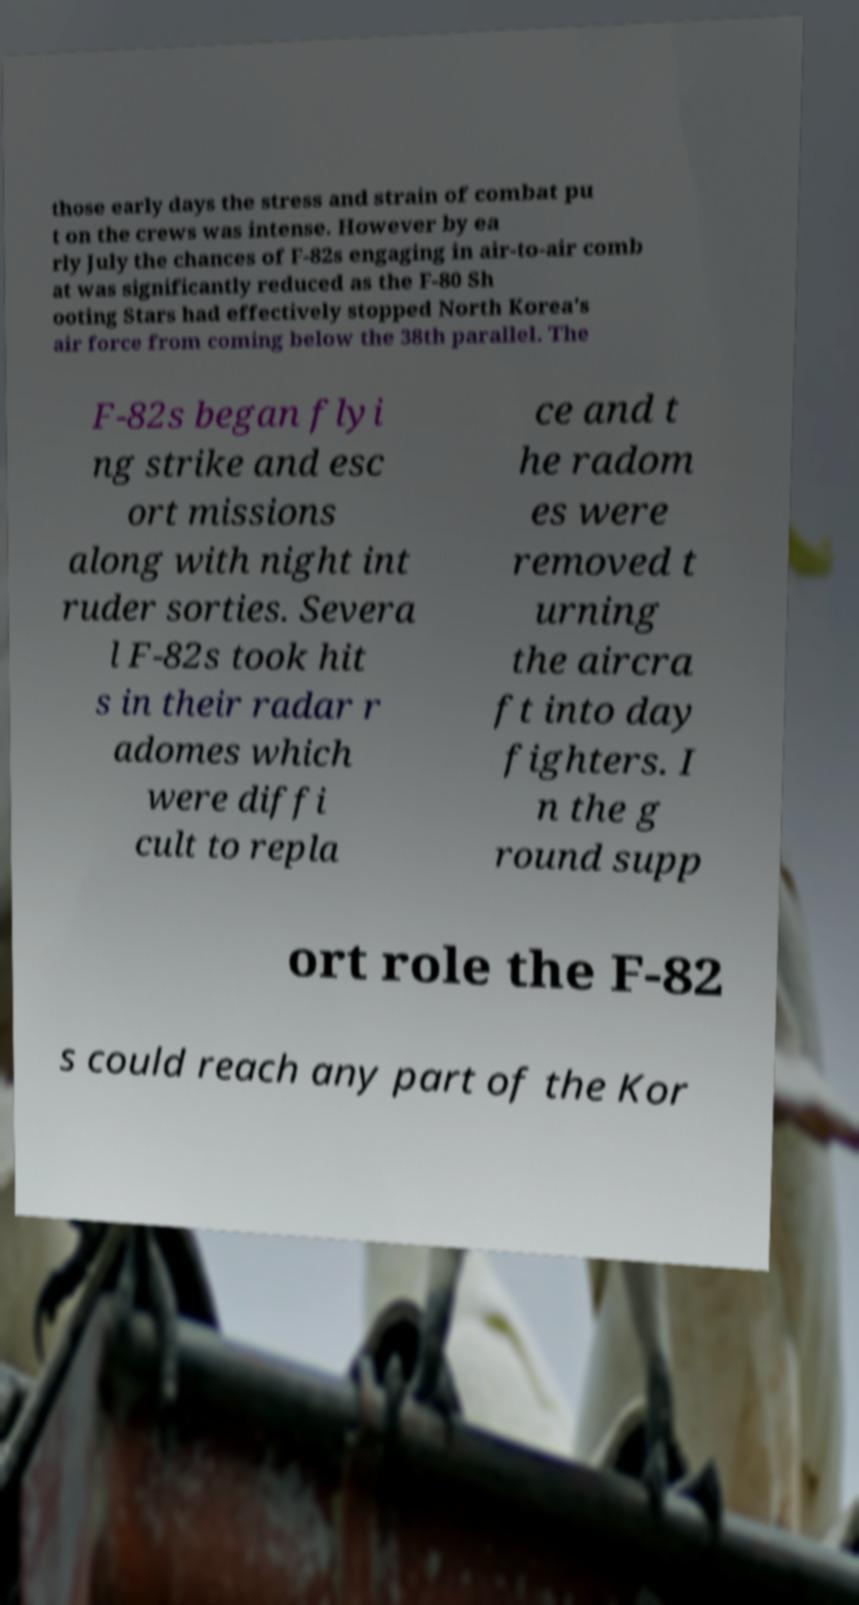There's text embedded in this image that I need extracted. Can you transcribe it verbatim? those early days the stress and strain of combat pu t on the crews was intense. However by ea rly July the chances of F-82s engaging in air-to-air comb at was significantly reduced as the F-80 Sh ooting Stars had effectively stopped North Korea's air force from coming below the 38th parallel. The F-82s began flyi ng strike and esc ort missions along with night int ruder sorties. Severa l F-82s took hit s in their radar r adomes which were diffi cult to repla ce and t he radom es were removed t urning the aircra ft into day fighters. I n the g round supp ort role the F-82 s could reach any part of the Kor 